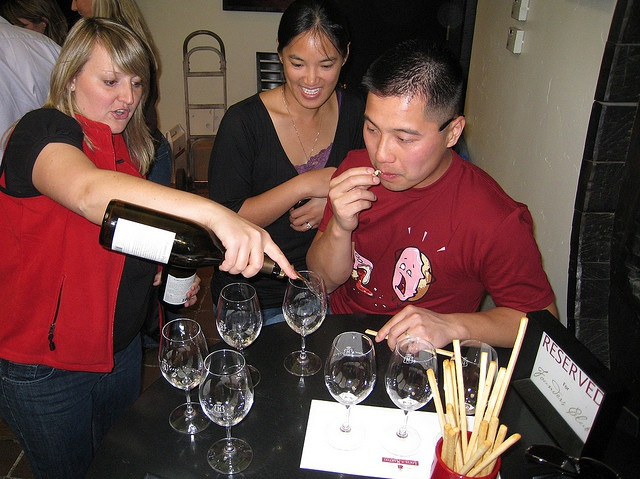Describe the objects in this image and their specific colors. I can see people in black, brown, tan, and gray tones, dining table in black, white, gray, and khaki tones, people in black, maroon, brown, and salmon tones, people in black, salmon, and tan tones, and dining table in black and gray tones in this image. 